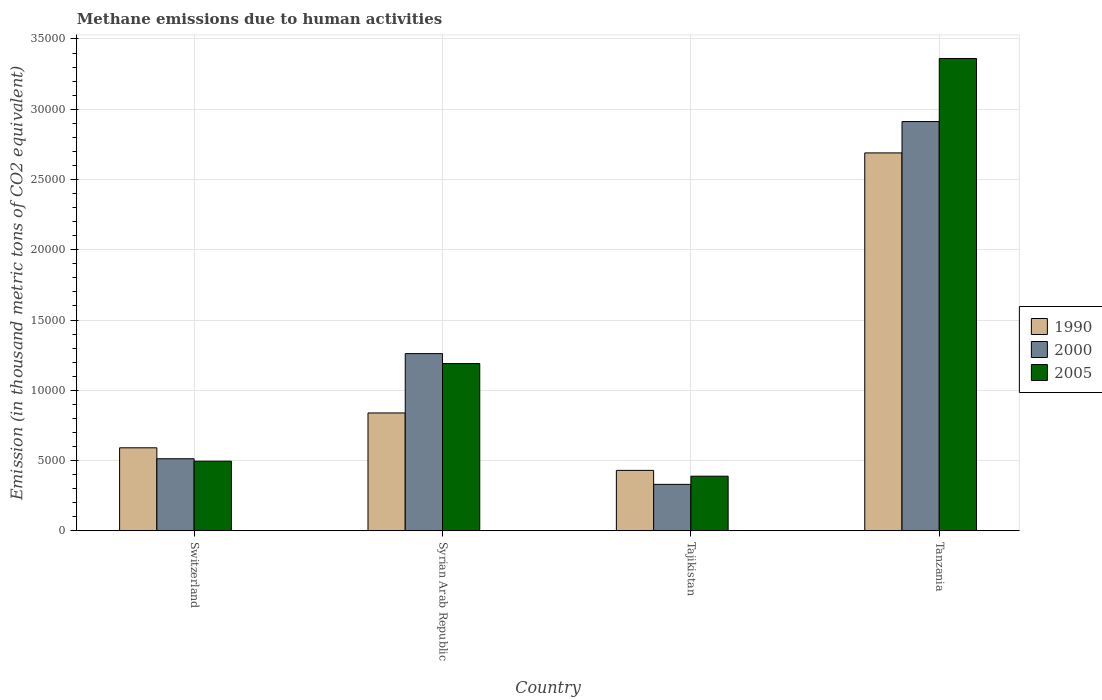Are the number of bars per tick equal to the number of legend labels?
Your response must be concise. Yes. What is the label of the 1st group of bars from the left?
Provide a short and direct response. Switzerland. In how many cases, is the number of bars for a given country not equal to the number of legend labels?
Offer a very short reply. 0. What is the amount of methane emitted in 2000 in Switzerland?
Keep it short and to the point. 5126.2. Across all countries, what is the maximum amount of methane emitted in 1990?
Your answer should be very brief. 2.69e+04. Across all countries, what is the minimum amount of methane emitted in 2000?
Your answer should be very brief. 3303.6. In which country was the amount of methane emitted in 1990 maximum?
Provide a short and direct response. Tanzania. In which country was the amount of methane emitted in 1990 minimum?
Offer a terse response. Tajikistan. What is the total amount of methane emitted in 2000 in the graph?
Offer a terse response. 5.02e+04. What is the difference between the amount of methane emitted in 2000 in Syrian Arab Republic and that in Tanzania?
Ensure brevity in your answer.  -1.65e+04. What is the difference between the amount of methane emitted in 2005 in Syrian Arab Republic and the amount of methane emitted in 2000 in Tajikistan?
Your response must be concise. 8597.6. What is the average amount of methane emitted in 2005 per country?
Offer a very short reply. 1.36e+04. What is the difference between the amount of methane emitted of/in 1990 and amount of methane emitted of/in 2000 in Tanzania?
Offer a terse response. -2232.7. What is the ratio of the amount of methane emitted in 2005 in Syrian Arab Republic to that in Tajikistan?
Provide a succinct answer. 3.06. Is the amount of methane emitted in 2005 in Switzerland less than that in Syrian Arab Republic?
Provide a short and direct response. Yes. Is the difference between the amount of methane emitted in 1990 in Syrian Arab Republic and Tajikistan greater than the difference between the amount of methane emitted in 2000 in Syrian Arab Republic and Tajikistan?
Give a very brief answer. No. What is the difference between the highest and the second highest amount of methane emitted in 1990?
Provide a succinct answer. 2480.1. What is the difference between the highest and the lowest amount of methane emitted in 2005?
Give a very brief answer. 2.97e+04. Is it the case that in every country, the sum of the amount of methane emitted in 2000 and amount of methane emitted in 2005 is greater than the amount of methane emitted in 1990?
Your response must be concise. Yes. How many bars are there?
Give a very brief answer. 12. What is the difference between two consecutive major ticks on the Y-axis?
Your response must be concise. 5000. Does the graph contain any zero values?
Your response must be concise. No. Where does the legend appear in the graph?
Keep it short and to the point. Center right. How many legend labels are there?
Provide a succinct answer. 3. How are the legend labels stacked?
Make the answer very short. Vertical. What is the title of the graph?
Your answer should be compact. Methane emissions due to human activities. Does "2008" appear as one of the legend labels in the graph?
Make the answer very short. No. What is the label or title of the Y-axis?
Make the answer very short. Emission (in thousand metric tons of CO2 equivalent). What is the Emission (in thousand metric tons of CO2 equivalent) of 1990 in Switzerland?
Offer a terse response. 5904.8. What is the Emission (in thousand metric tons of CO2 equivalent) in 2000 in Switzerland?
Make the answer very short. 5126.2. What is the Emission (in thousand metric tons of CO2 equivalent) of 2005 in Switzerland?
Give a very brief answer. 4953.4. What is the Emission (in thousand metric tons of CO2 equivalent) in 1990 in Syrian Arab Republic?
Your answer should be very brief. 8384.9. What is the Emission (in thousand metric tons of CO2 equivalent) of 2000 in Syrian Arab Republic?
Ensure brevity in your answer.  1.26e+04. What is the Emission (in thousand metric tons of CO2 equivalent) of 2005 in Syrian Arab Republic?
Keep it short and to the point. 1.19e+04. What is the Emission (in thousand metric tons of CO2 equivalent) of 1990 in Tajikistan?
Your response must be concise. 4299. What is the Emission (in thousand metric tons of CO2 equivalent) of 2000 in Tajikistan?
Your answer should be compact. 3303.6. What is the Emission (in thousand metric tons of CO2 equivalent) in 2005 in Tajikistan?
Provide a succinct answer. 3884.9. What is the Emission (in thousand metric tons of CO2 equivalent) in 1990 in Tanzania?
Ensure brevity in your answer.  2.69e+04. What is the Emission (in thousand metric tons of CO2 equivalent) in 2000 in Tanzania?
Keep it short and to the point. 2.91e+04. What is the Emission (in thousand metric tons of CO2 equivalent) of 2005 in Tanzania?
Provide a succinct answer. 3.36e+04. Across all countries, what is the maximum Emission (in thousand metric tons of CO2 equivalent) in 1990?
Give a very brief answer. 2.69e+04. Across all countries, what is the maximum Emission (in thousand metric tons of CO2 equivalent) of 2000?
Offer a very short reply. 2.91e+04. Across all countries, what is the maximum Emission (in thousand metric tons of CO2 equivalent) in 2005?
Provide a short and direct response. 3.36e+04. Across all countries, what is the minimum Emission (in thousand metric tons of CO2 equivalent) in 1990?
Ensure brevity in your answer.  4299. Across all countries, what is the minimum Emission (in thousand metric tons of CO2 equivalent) of 2000?
Offer a very short reply. 3303.6. Across all countries, what is the minimum Emission (in thousand metric tons of CO2 equivalent) in 2005?
Make the answer very short. 3884.9. What is the total Emission (in thousand metric tons of CO2 equivalent) of 1990 in the graph?
Provide a succinct answer. 4.55e+04. What is the total Emission (in thousand metric tons of CO2 equivalent) in 2000 in the graph?
Your answer should be compact. 5.02e+04. What is the total Emission (in thousand metric tons of CO2 equivalent) in 2005 in the graph?
Your answer should be compact. 5.43e+04. What is the difference between the Emission (in thousand metric tons of CO2 equivalent) of 1990 in Switzerland and that in Syrian Arab Republic?
Your response must be concise. -2480.1. What is the difference between the Emission (in thousand metric tons of CO2 equivalent) of 2000 in Switzerland and that in Syrian Arab Republic?
Your response must be concise. -7482.6. What is the difference between the Emission (in thousand metric tons of CO2 equivalent) in 2005 in Switzerland and that in Syrian Arab Republic?
Offer a very short reply. -6947.8. What is the difference between the Emission (in thousand metric tons of CO2 equivalent) in 1990 in Switzerland and that in Tajikistan?
Offer a terse response. 1605.8. What is the difference between the Emission (in thousand metric tons of CO2 equivalent) of 2000 in Switzerland and that in Tajikistan?
Your response must be concise. 1822.6. What is the difference between the Emission (in thousand metric tons of CO2 equivalent) of 2005 in Switzerland and that in Tajikistan?
Give a very brief answer. 1068.5. What is the difference between the Emission (in thousand metric tons of CO2 equivalent) of 1990 in Switzerland and that in Tanzania?
Provide a short and direct response. -2.10e+04. What is the difference between the Emission (in thousand metric tons of CO2 equivalent) of 2000 in Switzerland and that in Tanzania?
Give a very brief answer. -2.40e+04. What is the difference between the Emission (in thousand metric tons of CO2 equivalent) of 2005 in Switzerland and that in Tanzania?
Your answer should be compact. -2.87e+04. What is the difference between the Emission (in thousand metric tons of CO2 equivalent) in 1990 in Syrian Arab Republic and that in Tajikistan?
Make the answer very short. 4085.9. What is the difference between the Emission (in thousand metric tons of CO2 equivalent) of 2000 in Syrian Arab Republic and that in Tajikistan?
Provide a short and direct response. 9305.2. What is the difference between the Emission (in thousand metric tons of CO2 equivalent) in 2005 in Syrian Arab Republic and that in Tajikistan?
Make the answer very short. 8016.3. What is the difference between the Emission (in thousand metric tons of CO2 equivalent) in 1990 in Syrian Arab Republic and that in Tanzania?
Make the answer very short. -1.85e+04. What is the difference between the Emission (in thousand metric tons of CO2 equivalent) in 2000 in Syrian Arab Republic and that in Tanzania?
Your answer should be compact. -1.65e+04. What is the difference between the Emission (in thousand metric tons of CO2 equivalent) in 2005 in Syrian Arab Republic and that in Tanzania?
Offer a very short reply. -2.17e+04. What is the difference between the Emission (in thousand metric tons of CO2 equivalent) in 1990 in Tajikistan and that in Tanzania?
Your answer should be compact. -2.26e+04. What is the difference between the Emission (in thousand metric tons of CO2 equivalent) in 2000 in Tajikistan and that in Tanzania?
Provide a short and direct response. -2.58e+04. What is the difference between the Emission (in thousand metric tons of CO2 equivalent) of 2005 in Tajikistan and that in Tanzania?
Keep it short and to the point. -2.97e+04. What is the difference between the Emission (in thousand metric tons of CO2 equivalent) of 1990 in Switzerland and the Emission (in thousand metric tons of CO2 equivalent) of 2000 in Syrian Arab Republic?
Your answer should be very brief. -6704. What is the difference between the Emission (in thousand metric tons of CO2 equivalent) of 1990 in Switzerland and the Emission (in thousand metric tons of CO2 equivalent) of 2005 in Syrian Arab Republic?
Provide a succinct answer. -5996.4. What is the difference between the Emission (in thousand metric tons of CO2 equivalent) of 2000 in Switzerland and the Emission (in thousand metric tons of CO2 equivalent) of 2005 in Syrian Arab Republic?
Your response must be concise. -6775. What is the difference between the Emission (in thousand metric tons of CO2 equivalent) of 1990 in Switzerland and the Emission (in thousand metric tons of CO2 equivalent) of 2000 in Tajikistan?
Provide a succinct answer. 2601.2. What is the difference between the Emission (in thousand metric tons of CO2 equivalent) in 1990 in Switzerland and the Emission (in thousand metric tons of CO2 equivalent) in 2005 in Tajikistan?
Your answer should be very brief. 2019.9. What is the difference between the Emission (in thousand metric tons of CO2 equivalent) in 2000 in Switzerland and the Emission (in thousand metric tons of CO2 equivalent) in 2005 in Tajikistan?
Ensure brevity in your answer.  1241.3. What is the difference between the Emission (in thousand metric tons of CO2 equivalent) in 1990 in Switzerland and the Emission (in thousand metric tons of CO2 equivalent) in 2000 in Tanzania?
Keep it short and to the point. -2.32e+04. What is the difference between the Emission (in thousand metric tons of CO2 equivalent) of 1990 in Switzerland and the Emission (in thousand metric tons of CO2 equivalent) of 2005 in Tanzania?
Provide a succinct answer. -2.77e+04. What is the difference between the Emission (in thousand metric tons of CO2 equivalent) of 2000 in Switzerland and the Emission (in thousand metric tons of CO2 equivalent) of 2005 in Tanzania?
Offer a terse response. -2.85e+04. What is the difference between the Emission (in thousand metric tons of CO2 equivalent) of 1990 in Syrian Arab Republic and the Emission (in thousand metric tons of CO2 equivalent) of 2000 in Tajikistan?
Provide a succinct answer. 5081.3. What is the difference between the Emission (in thousand metric tons of CO2 equivalent) in 1990 in Syrian Arab Republic and the Emission (in thousand metric tons of CO2 equivalent) in 2005 in Tajikistan?
Make the answer very short. 4500. What is the difference between the Emission (in thousand metric tons of CO2 equivalent) of 2000 in Syrian Arab Republic and the Emission (in thousand metric tons of CO2 equivalent) of 2005 in Tajikistan?
Keep it short and to the point. 8723.9. What is the difference between the Emission (in thousand metric tons of CO2 equivalent) in 1990 in Syrian Arab Republic and the Emission (in thousand metric tons of CO2 equivalent) in 2000 in Tanzania?
Provide a short and direct response. -2.07e+04. What is the difference between the Emission (in thousand metric tons of CO2 equivalent) of 1990 in Syrian Arab Republic and the Emission (in thousand metric tons of CO2 equivalent) of 2005 in Tanzania?
Keep it short and to the point. -2.52e+04. What is the difference between the Emission (in thousand metric tons of CO2 equivalent) in 2000 in Syrian Arab Republic and the Emission (in thousand metric tons of CO2 equivalent) in 2005 in Tanzania?
Ensure brevity in your answer.  -2.10e+04. What is the difference between the Emission (in thousand metric tons of CO2 equivalent) in 1990 in Tajikistan and the Emission (in thousand metric tons of CO2 equivalent) in 2000 in Tanzania?
Offer a terse response. -2.48e+04. What is the difference between the Emission (in thousand metric tons of CO2 equivalent) in 1990 in Tajikistan and the Emission (in thousand metric tons of CO2 equivalent) in 2005 in Tanzania?
Your response must be concise. -2.93e+04. What is the difference between the Emission (in thousand metric tons of CO2 equivalent) of 2000 in Tajikistan and the Emission (in thousand metric tons of CO2 equivalent) of 2005 in Tanzania?
Provide a short and direct response. -3.03e+04. What is the average Emission (in thousand metric tons of CO2 equivalent) in 1990 per country?
Your response must be concise. 1.14e+04. What is the average Emission (in thousand metric tons of CO2 equivalent) of 2000 per country?
Provide a short and direct response. 1.25e+04. What is the average Emission (in thousand metric tons of CO2 equivalent) in 2005 per country?
Your answer should be very brief. 1.36e+04. What is the difference between the Emission (in thousand metric tons of CO2 equivalent) in 1990 and Emission (in thousand metric tons of CO2 equivalent) in 2000 in Switzerland?
Make the answer very short. 778.6. What is the difference between the Emission (in thousand metric tons of CO2 equivalent) of 1990 and Emission (in thousand metric tons of CO2 equivalent) of 2005 in Switzerland?
Your response must be concise. 951.4. What is the difference between the Emission (in thousand metric tons of CO2 equivalent) in 2000 and Emission (in thousand metric tons of CO2 equivalent) in 2005 in Switzerland?
Give a very brief answer. 172.8. What is the difference between the Emission (in thousand metric tons of CO2 equivalent) in 1990 and Emission (in thousand metric tons of CO2 equivalent) in 2000 in Syrian Arab Republic?
Your answer should be very brief. -4223.9. What is the difference between the Emission (in thousand metric tons of CO2 equivalent) of 1990 and Emission (in thousand metric tons of CO2 equivalent) of 2005 in Syrian Arab Republic?
Your response must be concise. -3516.3. What is the difference between the Emission (in thousand metric tons of CO2 equivalent) of 2000 and Emission (in thousand metric tons of CO2 equivalent) of 2005 in Syrian Arab Republic?
Your answer should be compact. 707.6. What is the difference between the Emission (in thousand metric tons of CO2 equivalent) in 1990 and Emission (in thousand metric tons of CO2 equivalent) in 2000 in Tajikistan?
Offer a terse response. 995.4. What is the difference between the Emission (in thousand metric tons of CO2 equivalent) in 1990 and Emission (in thousand metric tons of CO2 equivalent) in 2005 in Tajikistan?
Make the answer very short. 414.1. What is the difference between the Emission (in thousand metric tons of CO2 equivalent) in 2000 and Emission (in thousand metric tons of CO2 equivalent) in 2005 in Tajikistan?
Make the answer very short. -581.3. What is the difference between the Emission (in thousand metric tons of CO2 equivalent) in 1990 and Emission (in thousand metric tons of CO2 equivalent) in 2000 in Tanzania?
Your answer should be very brief. -2232.7. What is the difference between the Emission (in thousand metric tons of CO2 equivalent) in 1990 and Emission (in thousand metric tons of CO2 equivalent) in 2005 in Tanzania?
Give a very brief answer. -6719. What is the difference between the Emission (in thousand metric tons of CO2 equivalent) in 2000 and Emission (in thousand metric tons of CO2 equivalent) in 2005 in Tanzania?
Your response must be concise. -4486.3. What is the ratio of the Emission (in thousand metric tons of CO2 equivalent) in 1990 in Switzerland to that in Syrian Arab Republic?
Ensure brevity in your answer.  0.7. What is the ratio of the Emission (in thousand metric tons of CO2 equivalent) in 2000 in Switzerland to that in Syrian Arab Republic?
Provide a short and direct response. 0.41. What is the ratio of the Emission (in thousand metric tons of CO2 equivalent) of 2005 in Switzerland to that in Syrian Arab Republic?
Your answer should be compact. 0.42. What is the ratio of the Emission (in thousand metric tons of CO2 equivalent) of 1990 in Switzerland to that in Tajikistan?
Ensure brevity in your answer.  1.37. What is the ratio of the Emission (in thousand metric tons of CO2 equivalent) in 2000 in Switzerland to that in Tajikistan?
Your answer should be very brief. 1.55. What is the ratio of the Emission (in thousand metric tons of CO2 equivalent) of 2005 in Switzerland to that in Tajikistan?
Keep it short and to the point. 1.27. What is the ratio of the Emission (in thousand metric tons of CO2 equivalent) of 1990 in Switzerland to that in Tanzania?
Keep it short and to the point. 0.22. What is the ratio of the Emission (in thousand metric tons of CO2 equivalent) of 2000 in Switzerland to that in Tanzania?
Your answer should be very brief. 0.18. What is the ratio of the Emission (in thousand metric tons of CO2 equivalent) of 2005 in Switzerland to that in Tanzania?
Your answer should be compact. 0.15. What is the ratio of the Emission (in thousand metric tons of CO2 equivalent) in 1990 in Syrian Arab Republic to that in Tajikistan?
Your answer should be very brief. 1.95. What is the ratio of the Emission (in thousand metric tons of CO2 equivalent) in 2000 in Syrian Arab Republic to that in Tajikistan?
Provide a succinct answer. 3.82. What is the ratio of the Emission (in thousand metric tons of CO2 equivalent) of 2005 in Syrian Arab Republic to that in Tajikistan?
Ensure brevity in your answer.  3.06. What is the ratio of the Emission (in thousand metric tons of CO2 equivalent) in 1990 in Syrian Arab Republic to that in Tanzania?
Keep it short and to the point. 0.31. What is the ratio of the Emission (in thousand metric tons of CO2 equivalent) in 2000 in Syrian Arab Republic to that in Tanzania?
Your answer should be compact. 0.43. What is the ratio of the Emission (in thousand metric tons of CO2 equivalent) of 2005 in Syrian Arab Republic to that in Tanzania?
Offer a terse response. 0.35. What is the ratio of the Emission (in thousand metric tons of CO2 equivalent) in 1990 in Tajikistan to that in Tanzania?
Your response must be concise. 0.16. What is the ratio of the Emission (in thousand metric tons of CO2 equivalent) in 2000 in Tajikistan to that in Tanzania?
Your answer should be compact. 0.11. What is the ratio of the Emission (in thousand metric tons of CO2 equivalent) in 2005 in Tajikistan to that in Tanzania?
Make the answer very short. 0.12. What is the difference between the highest and the second highest Emission (in thousand metric tons of CO2 equivalent) in 1990?
Keep it short and to the point. 1.85e+04. What is the difference between the highest and the second highest Emission (in thousand metric tons of CO2 equivalent) of 2000?
Your response must be concise. 1.65e+04. What is the difference between the highest and the second highest Emission (in thousand metric tons of CO2 equivalent) of 2005?
Give a very brief answer. 2.17e+04. What is the difference between the highest and the lowest Emission (in thousand metric tons of CO2 equivalent) of 1990?
Offer a terse response. 2.26e+04. What is the difference between the highest and the lowest Emission (in thousand metric tons of CO2 equivalent) of 2000?
Your answer should be compact. 2.58e+04. What is the difference between the highest and the lowest Emission (in thousand metric tons of CO2 equivalent) in 2005?
Provide a succinct answer. 2.97e+04. 